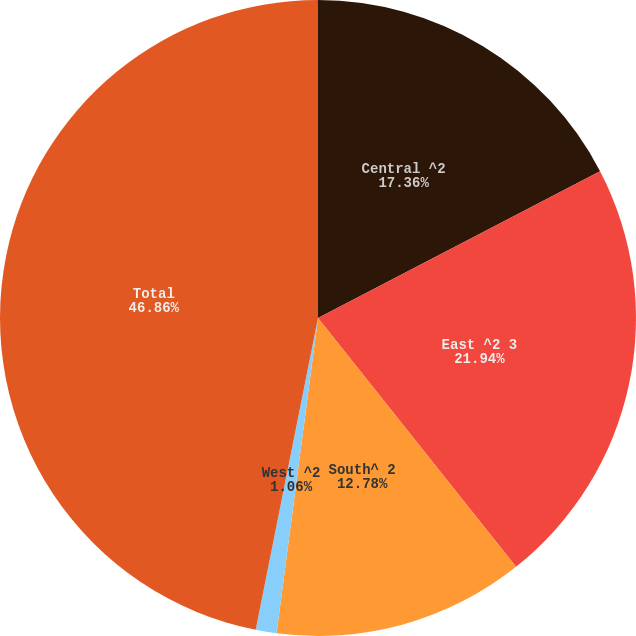Convert chart to OTSL. <chart><loc_0><loc_0><loc_500><loc_500><pie_chart><fcel>Central ^2<fcel>East ^2 3<fcel>South^ 2<fcel>West ^2<fcel>Total<nl><fcel>17.36%<fcel>21.94%<fcel>12.78%<fcel>1.06%<fcel>46.86%<nl></chart> 